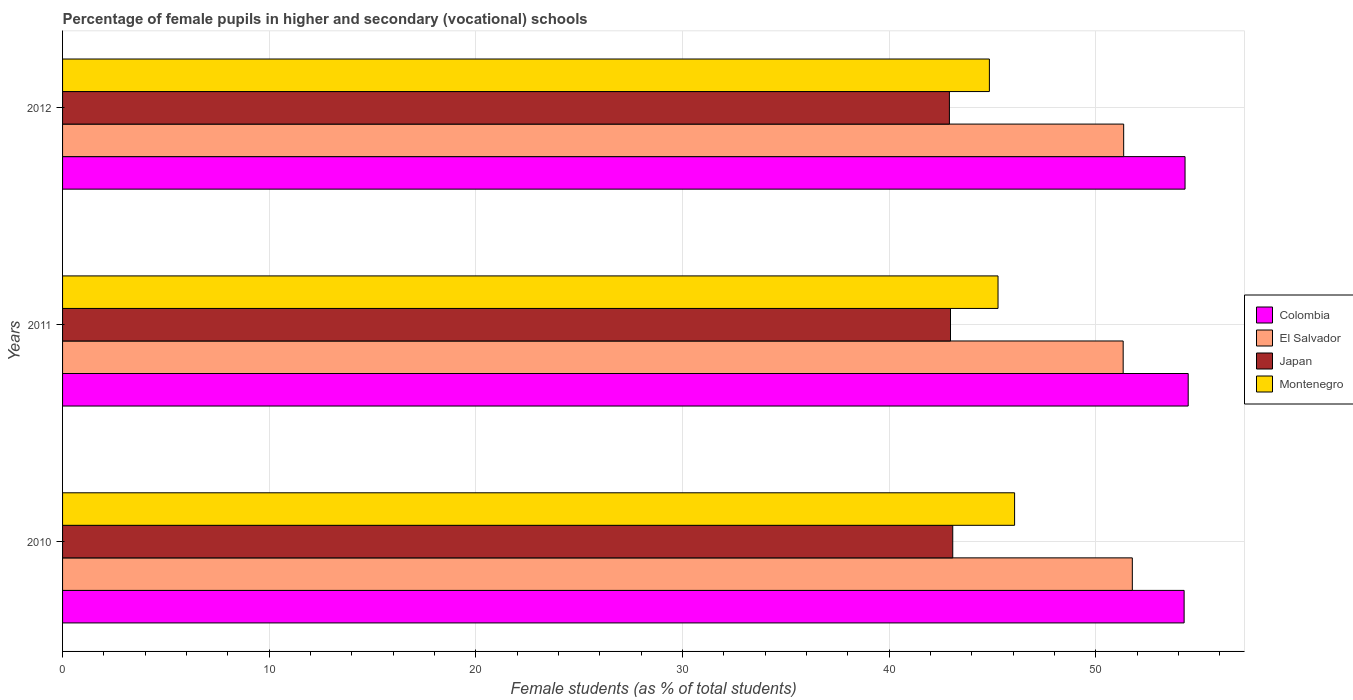How many different coloured bars are there?
Ensure brevity in your answer.  4. Are the number of bars per tick equal to the number of legend labels?
Your answer should be compact. Yes. How many bars are there on the 3rd tick from the top?
Make the answer very short. 4. What is the label of the 2nd group of bars from the top?
Ensure brevity in your answer.  2011. In how many cases, is the number of bars for a given year not equal to the number of legend labels?
Your response must be concise. 0. What is the percentage of female pupils in higher and secondary schools in Montenegro in 2010?
Provide a short and direct response. 46.08. Across all years, what is the maximum percentage of female pupils in higher and secondary schools in Japan?
Ensure brevity in your answer.  43.08. Across all years, what is the minimum percentage of female pupils in higher and secondary schools in Colombia?
Ensure brevity in your answer.  54.28. In which year was the percentage of female pupils in higher and secondary schools in Colombia maximum?
Your answer should be compact. 2011. In which year was the percentage of female pupils in higher and secondary schools in Japan minimum?
Offer a terse response. 2012. What is the total percentage of female pupils in higher and secondary schools in Colombia in the graph?
Your answer should be very brief. 163.08. What is the difference between the percentage of female pupils in higher and secondary schools in Colombia in 2011 and that in 2012?
Your answer should be very brief. 0.15. What is the difference between the percentage of female pupils in higher and secondary schools in Colombia in 2011 and the percentage of female pupils in higher and secondary schools in Japan in 2012?
Ensure brevity in your answer.  11.56. What is the average percentage of female pupils in higher and secondary schools in Montenegro per year?
Your answer should be very brief. 45.4. In the year 2011, what is the difference between the percentage of female pupils in higher and secondary schools in Montenegro and percentage of female pupils in higher and secondary schools in El Salvador?
Keep it short and to the point. -6.06. What is the ratio of the percentage of female pupils in higher and secondary schools in Montenegro in 2011 to that in 2012?
Provide a succinct answer. 1.01. What is the difference between the highest and the second highest percentage of female pupils in higher and secondary schools in El Salvador?
Your answer should be very brief. 0.42. What is the difference between the highest and the lowest percentage of female pupils in higher and secondary schools in Japan?
Your response must be concise. 0.16. Is it the case that in every year, the sum of the percentage of female pupils in higher and secondary schools in Montenegro and percentage of female pupils in higher and secondary schools in Japan is greater than the sum of percentage of female pupils in higher and secondary schools in El Salvador and percentage of female pupils in higher and secondary schools in Colombia?
Keep it short and to the point. No. What does the 4th bar from the top in 2012 represents?
Give a very brief answer. Colombia. What does the 2nd bar from the bottom in 2012 represents?
Keep it short and to the point. El Salvador. Is it the case that in every year, the sum of the percentage of female pupils in higher and secondary schools in Japan and percentage of female pupils in higher and secondary schools in Colombia is greater than the percentage of female pupils in higher and secondary schools in El Salvador?
Offer a terse response. Yes. Are all the bars in the graph horizontal?
Keep it short and to the point. Yes. What is the difference between two consecutive major ticks on the X-axis?
Offer a very short reply. 10. How many legend labels are there?
Offer a very short reply. 4. What is the title of the graph?
Provide a succinct answer. Percentage of female pupils in higher and secondary (vocational) schools. What is the label or title of the X-axis?
Offer a very short reply. Female students (as % of total students). What is the Female students (as % of total students) of Colombia in 2010?
Ensure brevity in your answer.  54.28. What is the Female students (as % of total students) of El Salvador in 2010?
Offer a very short reply. 51.77. What is the Female students (as % of total students) of Japan in 2010?
Provide a short and direct response. 43.08. What is the Female students (as % of total students) in Montenegro in 2010?
Ensure brevity in your answer.  46.08. What is the Female students (as % of total students) in Colombia in 2011?
Your response must be concise. 54.48. What is the Female students (as % of total students) of El Salvador in 2011?
Your response must be concise. 51.33. What is the Female students (as % of total students) in Japan in 2011?
Provide a succinct answer. 42.97. What is the Female students (as % of total students) of Montenegro in 2011?
Offer a very short reply. 45.27. What is the Female students (as % of total students) of Colombia in 2012?
Make the answer very short. 54.33. What is the Female students (as % of total students) of El Salvador in 2012?
Give a very brief answer. 51.36. What is the Female students (as % of total students) in Japan in 2012?
Provide a succinct answer. 42.92. What is the Female students (as % of total students) in Montenegro in 2012?
Offer a very short reply. 44.86. Across all years, what is the maximum Female students (as % of total students) of Colombia?
Provide a succinct answer. 54.48. Across all years, what is the maximum Female students (as % of total students) in El Salvador?
Your response must be concise. 51.77. Across all years, what is the maximum Female students (as % of total students) in Japan?
Your answer should be compact. 43.08. Across all years, what is the maximum Female students (as % of total students) of Montenegro?
Your response must be concise. 46.08. Across all years, what is the minimum Female students (as % of total students) of Colombia?
Your answer should be very brief. 54.28. Across all years, what is the minimum Female students (as % of total students) in El Salvador?
Your answer should be compact. 51.33. Across all years, what is the minimum Female students (as % of total students) of Japan?
Provide a succinct answer. 42.92. Across all years, what is the minimum Female students (as % of total students) of Montenegro?
Your response must be concise. 44.86. What is the total Female students (as % of total students) in Colombia in the graph?
Offer a very short reply. 163.08. What is the total Female students (as % of total students) of El Salvador in the graph?
Your response must be concise. 154.46. What is the total Female students (as % of total students) of Japan in the graph?
Your answer should be very brief. 128.98. What is the total Female students (as % of total students) in Montenegro in the graph?
Offer a terse response. 136.21. What is the difference between the Female students (as % of total students) of Colombia in 2010 and that in 2011?
Your response must be concise. -0.2. What is the difference between the Female students (as % of total students) in El Salvador in 2010 and that in 2011?
Offer a terse response. 0.44. What is the difference between the Female students (as % of total students) of Japan in 2010 and that in 2011?
Ensure brevity in your answer.  0.11. What is the difference between the Female students (as % of total students) of Montenegro in 2010 and that in 2011?
Your answer should be compact. 0.8. What is the difference between the Female students (as % of total students) of Colombia in 2010 and that in 2012?
Keep it short and to the point. -0.04. What is the difference between the Female students (as % of total students) in El Salvador in 2010 and that in 2012?
Keep it short and to the point. 0.42. What is the difference between the Female students (as % of total students) in Japan in 2010 and that in 2012?
Give a very brief answer. 0.16. What is the difference between the Female students (as % of total students) in Montenegro in 2010 and that in 2012?
Provide a succinct answer. 1.22. What is the difference between the Female students (as % of total students) of Colombia in 2011 and that in 2012?
Offer a terse response. 0.15. What is the difference between the Female students (as % of total students) in El Salvador in 2011 and that in 2012?
Offer a terse response. -0.02. What is the difference between the Female students (as % of total students) in Japan in 2011 and that in 2012?
Your answer should be compact. 0.05. What is the difference between the Female students (as % of total students) of Montenegro in 2011 and that in 2012?
Ensure brevity in your answer.  0.42. What is the difference between the Female students (as % of total students) in Colombia in 2010 and the Female students (as % of total students) in El Salvador in 2011?
Provide a succinct answer. 2.95. What is the difference between the Female students (as % of total students) in Colombia in 2010 and the Female students (as % of total students) in Japan in 2011?
Ensure brevity in your answer.  11.31. What is the difference between the Female students (as % of total students) of Colombia in 2010 and the Female students (as % of total students) of Montenegro in 2011?
Ensure brevity in your answer.  9.01. What is the difference between the Female students (as % of total students) of El Salvador in 2010 and the Female students (as % of total students) of Japan in 2011?
Offer a very short reply. 8.8. What is the difference between the Female students (as % of total students) in El Salvador in 2010 and the Female students (as % of total students) in Montenegro in 2011?
Ensure brevity in your answer.  6.5. What is the difference between the Female students (as % of total students) in Japan in 2010 and the Female students (as % of total students) in Montenegro in 2011?
Provide a succinct answer. -2.19. What is the difference between the Female students (as % of total students) of Colombia in 2010 and the Female students (as % of total students) of El Salvador in 2012?
Keep it short and to the point. 2.93. What is the difference between the Female students (as % of total students) of Colombia in 2010 and the Female students (as % of total students) of Japan in 2012?
Keep it short and to the point. 11.36. What is the difference between the Female students (as % of total students) of Colombia in 2010 and the Female students (as % of total students) of Montenegro in 2012?
Give a very brief answer. 9.42. What is the difference between the Female students (as % of total students) of El Salvador in 2010 and the Female students (as % of total students) of Japan in 2012?
Offer a very short reply. 8.85. What is the difference between the Female students (as % of total students) in El Salvador in 2010 and the Female students (as % of total students) in Montenegro in 2012?
Your answer should be very brief. 6.92. What is the difference between the Female students (as % of total students) of Japan in 2010 and the Female students (as % of total students) of Montenegro in 2012?
Ensure brevity in your answer.  -1.77. What is the difference between the Female students (as % of total students) of Colombia in 2011 and the Female students (as % of total students) of El Salvador in 2012?
Offer a very short reply. 3.12. What is the difference between the Female students (as % of total students) in Colombia in 2011 and the Female students (as % of total students) in Japan in 2012?
Provide a succinct answer. 11.56. What is the difference between the Female students (as % of total students) in Colombia in 2011 and the Female students (as % of total students) in Montenegro in 2012?
Make the answer very short. 9.62. What is the difference between the Female students (as % of total students) of El Salvador in 2011 and the Female students (as % of total students) of Japan in 2012?
Ensure brevity in your answer.  8.41. What is the difference between the Female students (as % of total students) in El Salvador in 2011 and the Female students (as % of total students) in Montenegro in 2012?
Make the answer very short. 6.48. What is the difference between the Female students (as % of total students) of Japan in 2011 and the Female students (as % of total students) of Montenegro in 2012?
Ensure brevity in your answer.  -1.88. What is the average Female students (as % of total students) of Colombia per year?
Make the answer very short. 54.36. What is the average Female students (as % of total students) of El Salvador per year?
Ensure brevity in your answer.  51.49. What is the average Female students (as % of total students) in Japan per year?
Provide a short and direct response. 42.99. What is the average Female students (as % of total students) of Montenegro per year?
Your response must be concise. 45.4. In the year 2010, what is the difference between the Female students (as % of total students) of Colombia and Female students (as % of total students) of El Salvador?
Offer a terse response. 2.51. In the year 2010, what is the difference between the Female students (as % of total students) of Colombia and Female students (as % of total students) of Japan?
Your answer should be compact. 11.2. In the year 2010, what is the difference between the Female students (as % of total students) of Colombia and Female students (as % of total students) of Montenegro?
Provide a short and direct response. 8.21. In the year 2010, what is the difference between the Female students (as % of total students) of El Salvador and Female students (as % of total students) of Japan?
Your response must be concise. 8.69. In the year 2010, what is the difference between the Female students (as % of total students) of El Salvador and Female students (as % of total students) of Montenegro?
Provide a succinct answer. 5.7. In the year 2010, what is the difference between the Female students (as % of total students) in Japan and Female students (as % of total students) in Montenegro?
Provide a short and direct response. -2.99. In the year 2011, what is the difference between the Female students (as % of total students) in Colombia and Female students (as % of total students) in El Salvador?
Provide a succinct answer. 3.15. In the year 2011, what is the difference between the Female students (as % of total students) in Colombia and Female students (as % of total students) in Japan?
Give a very brief answer. 11.5. In the year 2011, what is the difference between the Female students (as % of total students) in Colombia and Female students (as % of total students) in Montenegro?
Provide a succinct answer. 9.2. In the year 2011, what is the difference between the Female students (as % of total students) in El Salvador and Female students (as % of total students) in Japan?
Your response must be concise. 8.36. In the year 2011, what is the difference between the Female students (as % of total students) of El Salvador and Female students (as % of total students) of Montenegro?
Your response must be concise. 6.06. In the year 2011, what is the difference between the Female students (as % of total students) in Japan and Female students (as % of total students) in Montenegro?
Your response must be concise. -2.3. In the year 2012, what is the difference between the Female students (as % of total students) of Colombia and Female students (as % of total students) of El Salvador?
Ensure brevity in your answer.  2.97. In the year 2012, what is the difference between the Female students (as % of total students) in Colombia and Female students (as % of total students) in Japan?
Your response must be concise. 11.4. In the year 2012, what is the difference between the Female students (as % of total students) in Colombia and Female students (as % of total students) in Montenegro?
Make the answer very short. 9.47. In the year 2012, what is the difference between the Female students (as % of total students) in El Salvador and Female students (as % of total students) in Japan?
Offer a terse response. 8.43. In the year 2012, what is the difference between the Female students (as % of total students) of El Salvador and Female students (as % of total students) of Montenegro?
Offer a very short reply. 6.5. In the year 2012, what is the difference between the Female students (as % of total students) of Japan and Female students (as % of total students) of Montenegro?
Keep it short and to the point. -1.94. What is the ratio of the Female students (as % of total students) of Colombia in 2010 to that in 2011?
Keep it short and to the point. 1. What is the ratio of the Female students (as % of total students) of El Salvador in 2010 to that in 2011?
Your answer should be very brief. 1.01. What is the ratio of the Female students (as % of total students) in Japan in 2010 to that in 2011?
Offer a very short reply. 1. What is the ratio of the Female students (as % of total students) of Montenegro in 2010 to that in 2011?
Your answer should be very brief. 1.02. What is the ratio of the Female students (as % of total students) of El Salvador in 2010 to that in 2012?
Your response must be concise. 1.01. What is the ratio of the Female students (as % of total students) of Japan in 2010 to that in 2012?
Provide a succinct answer. 1. What is the ratio of the Female students (as % of total students) in Montenegro in 2010 to that in 2012?
Your answer should be compact. 1.03. What is the ratio of the Female students (as % of total students) of Colombia in 2011 to that in 2012?
Provide a short and direct response. 1. What is the ratio of the Female students (as % of total students) of Japan in 2011 to that in 2012?
Make the answer very short. 1. What is the ratio of the Female students (as % of total students) in Montenegro in 2011 to that in 2012?
Make the answer very short. 1.01. What is the difference between the highest and the second highest Female students (as % of total students) of Colombia?
Ensure brevity in your answer.  0.15. What is the difference between the highest and the second highest Female students (as % of total students) in El Salvador?
Make the answer very short. 0.42. What is the difference between the highest and the second highest Female students (as % of total students) in Japan?
Your response must be concise. 0.11. What is the difference between the highest and the second highest Female students (as % of total students) of Montenegro?
Provide a succinct answer. 0.8. What is the difference between the highest and the lowest Female students (as % of total students) in Colombia?
Offer a terse response. 0.2. What is the difference between the highest and the lowest Female students (as % of total students) in El Salvador?
Give a very brief answer. 0.44. What is the difference between the highest and the lowest Female students (as % of total students) of Japan?
Your response must be concise. 0.16. What is the difference between the highest and the lowest Female students (as % of total students) of Montenegro?
Make the answer very short. 1.22. 